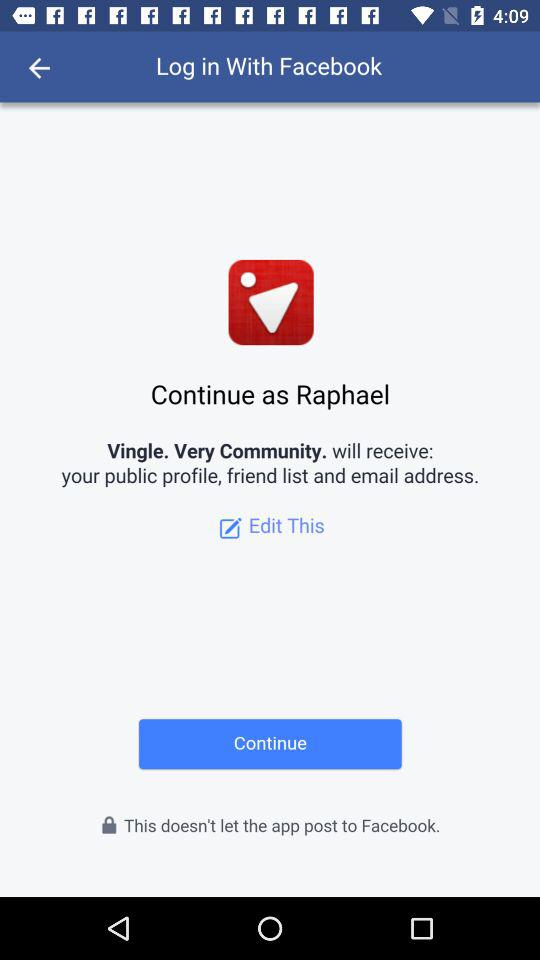What is the user's last name?
When the provided information is insufficient, respond with <no answer>. <no answer> 